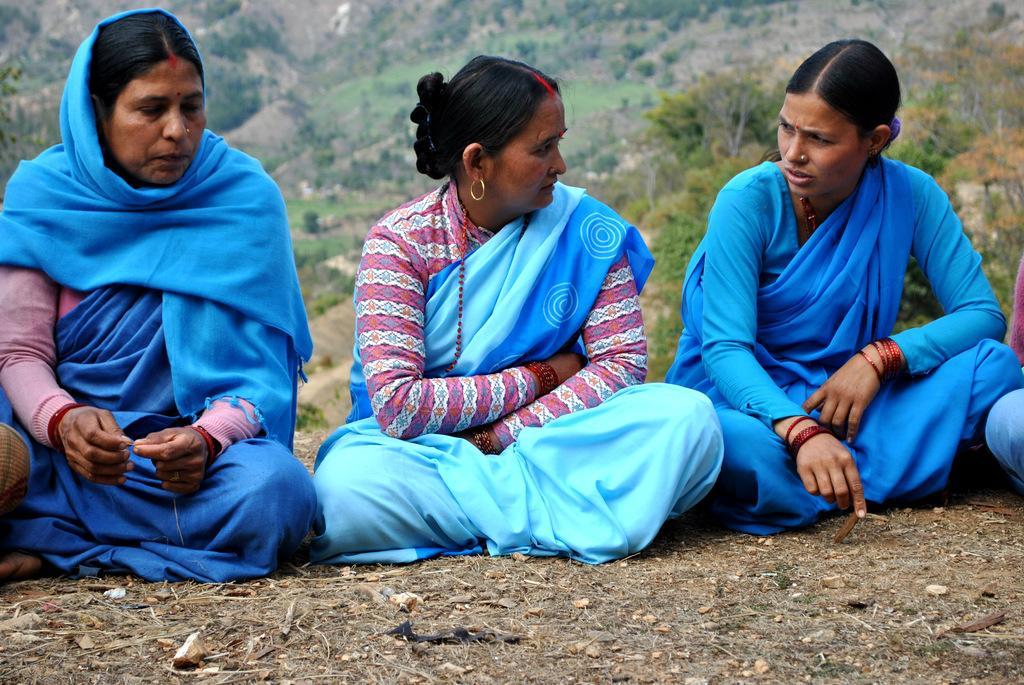Please provide a concise description of this image. In this image, there are three women sitting on the ground. In the background, I can see the hills and the trees. 